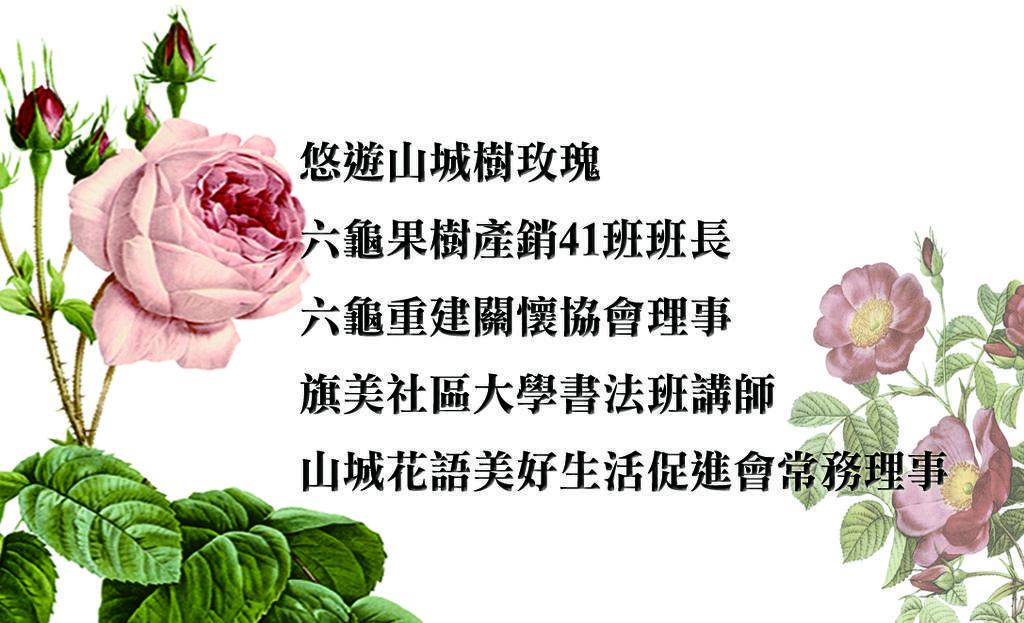Can you describe this image briefly? In this image, there is a picture, in that picture there are some pink color flower, at the left side there is a pink color rose, there are some green color leaves, there is something written in between the flowers. 